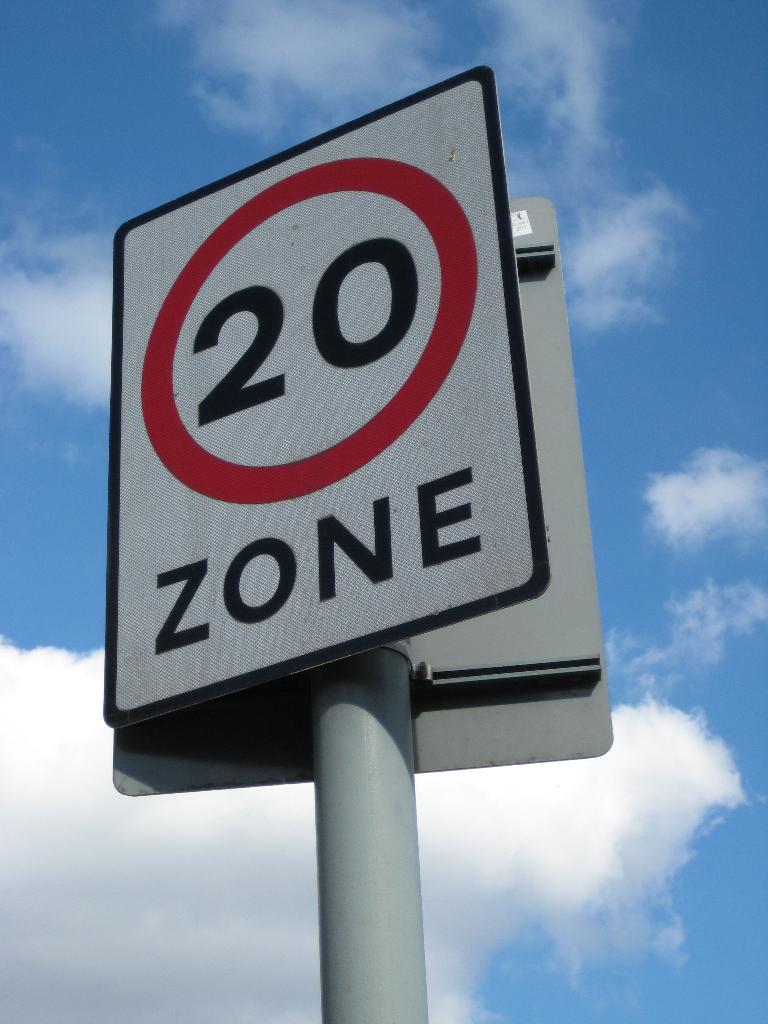What type of area is mentioned below the number 20?
Provide a short and direct response. Zone. 